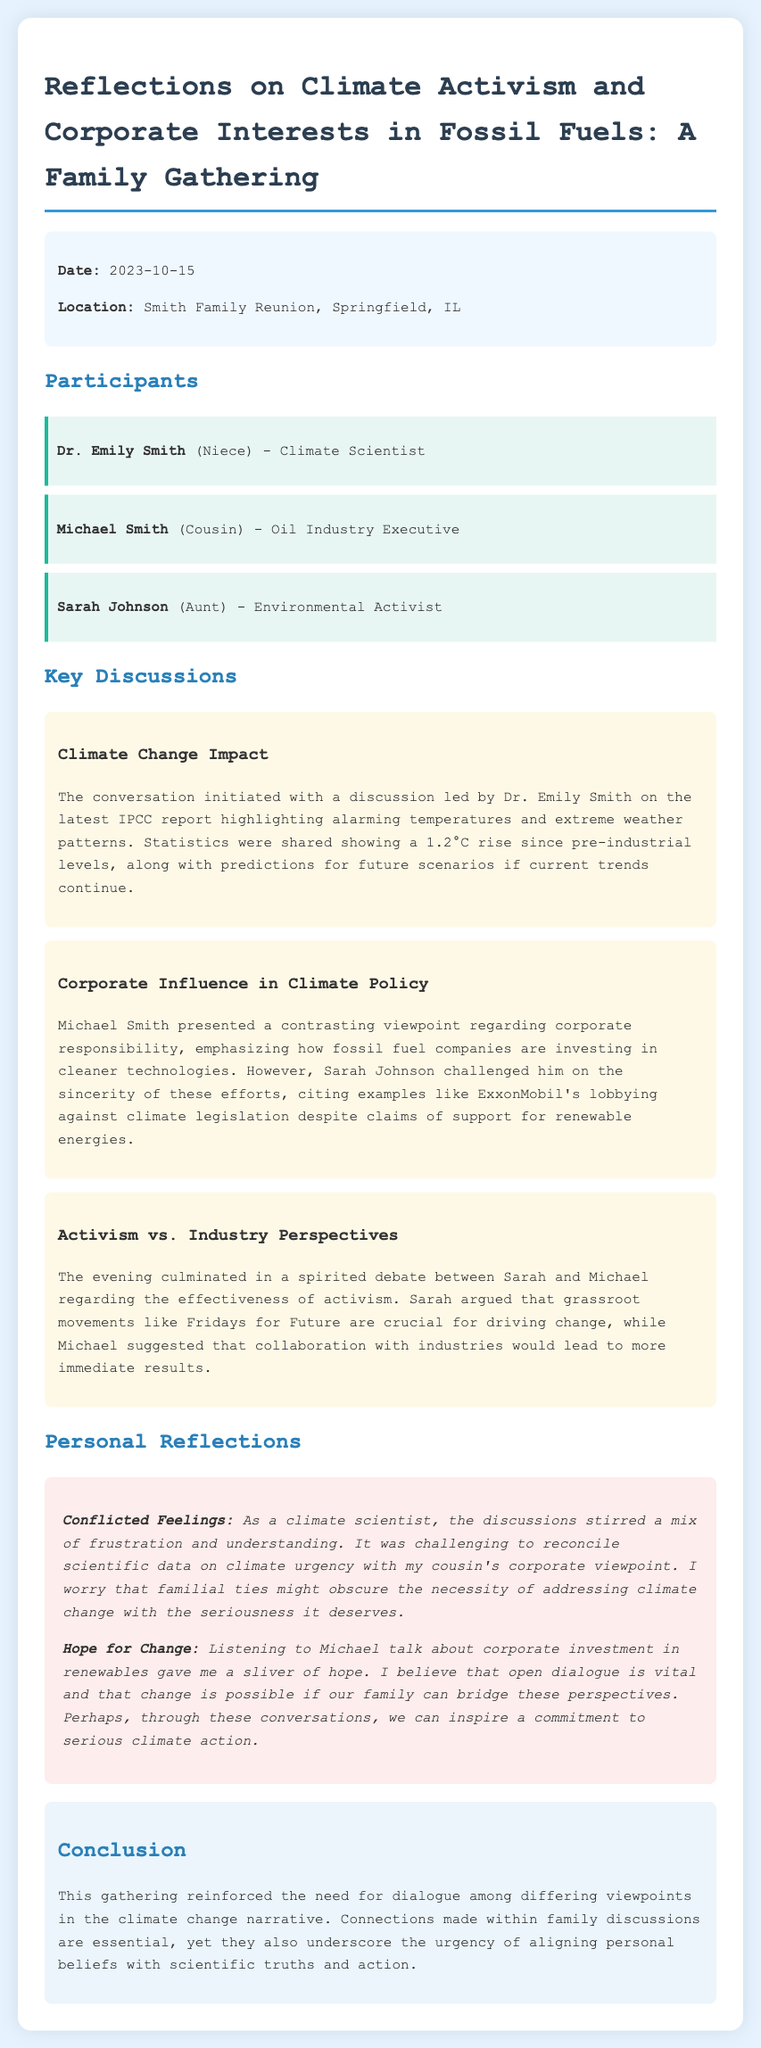what is the date of the family gathering? The date is specifically mentioned in the meta-info section of the document.
Answer: 2023-10-15 who led the discussion on the latest IPCC report? The document states that Dr. Emily Smith initiated the conversation regarding climate change impact.
Answer: Dr. Emily Smith what were the main climate statistics shared during the discussion? The statistics shared highlighted a 1.2°C rise since pre-industrial levels in the climate discussion.
Answer: 1.2°C how did Sarah Johnson challenge Michael Smith's viewpoint? The document indicates that Sarah cited examples of ExxonMobil's lobbying against climate legislation to challenge Michael's perspective.
Answer: Corporate lobbying what is the primary theme of the personal reflection section? The personal reflections express a mix of frustration and hope regarding the discussions on climate activism and corporate interests.
Answer: Conflicted feelings what contrasting viewpoints were discussed between Sarah and Michael? The discussion highlighted the effectiveness of grassroots activism versus collaboration with industries for immediate results.
Answer: Activism vs. Industry Perspectives what does the conclusion emphasize regarding differing viewpoints? The conclusion underlines the importance of dialogue and aligning personal beliefs with scientific truths and action.
Answer: Urgency of dialogue who among the participants is described as an environmental activist? The document identifies Sarah Johnson explicitly as the environmental activist in the family gathering.
Answer: Sarah Johnson what was the overall mood of the family discussion about climate issues? The document reflects a spirit of debate and discussion, indicating engagement and differing perspectives among family members.
Answer: Spirited debate 